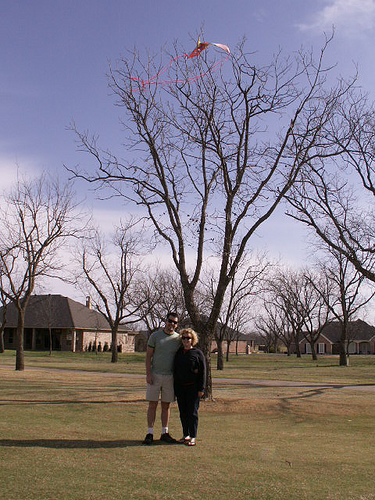<image>What animal is in the picture? It is ambiguous what animal is in the picture. It could be a human or a bird or there could be no animal. What animal is in the picture? I don't know what animal is in the picture. It can be a bird or a human. 